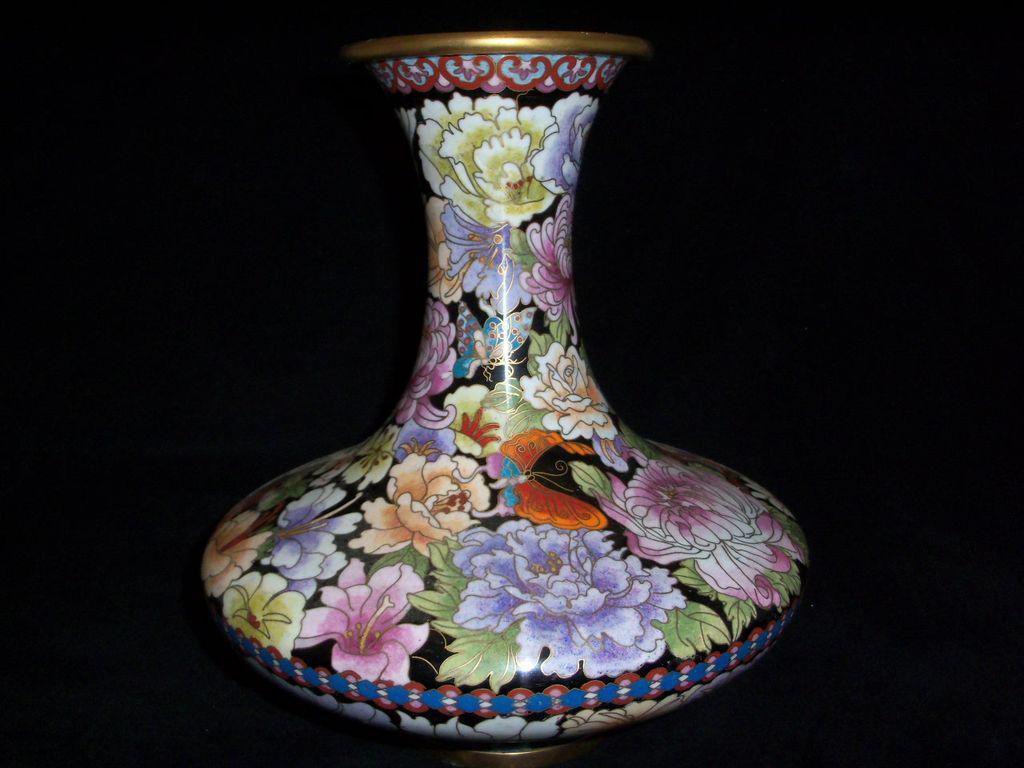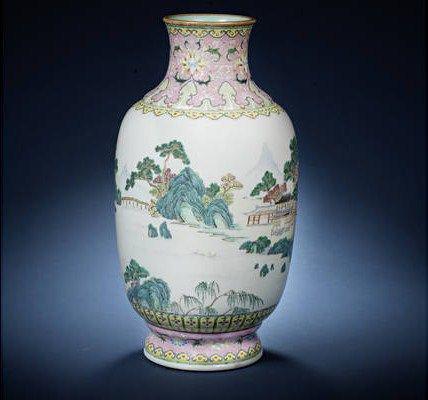The first image is the image on the left, the second image is the image on the right. Examine the images to the left and right. Is the description "One vase features a sky-blue background decorated with flowers and flying creatures." accurate? Answer yes or no. No. The first image is the image on the left, the second image is the image on the right. For the images shown, is this caption "One of the vases is predominantly white, while the other is mostly patterned." true? Answer yes or no. Yes. 